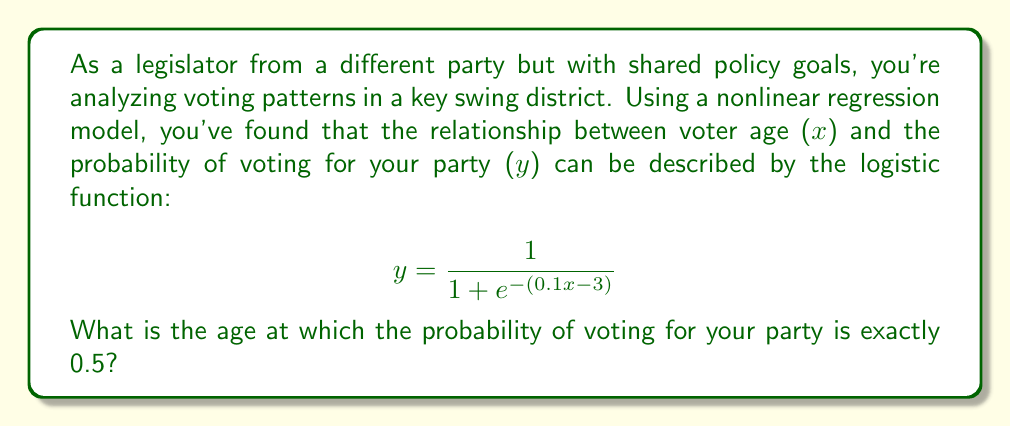What is the answer to this math problem? To solve this problem, we'll follow these steps:

1) The logistic function gives the probability of voting for your party. We want to find the age $x$ where this probability is 0.5.

2) We can set up the equation:

   $$0.5 = \frac{1}{1 + e^{-(0.1x - 3)}}$$

3) To solve this, we can manipulate the equation:
   
   Multiply both sides by the denominator:
   $$0.5(1 + e^{-(0.1x - 3)}) = 1$$
   
   Distribute on the left side:
   $$0.5 + 0.5e^{-(0.1x - 3)} = 1$$
   
   Subtract 0.5 from both sides:
   $$0.5e^{-(0.1x - 3)} = 0.5$$
   
   Divide both sides by 0.5:
   $$e^{-(0.1x - 3)} = 1$$

4) Now, we can take the natural log of both sides:
   
   $$-(0.1x - 3) = \ln(1) = 0$$

5) Simplify:
   $$0.1x - 3 = 0$$

6) Add 3 to both sides:
   $$0.1x = 3$$

7) Divide both sides by 0.1:
   $$x = 30$$

Therefore, the age at which the probability of voting for your party is exactly 0.5 is 30 years old.
Answer: 30 years old 